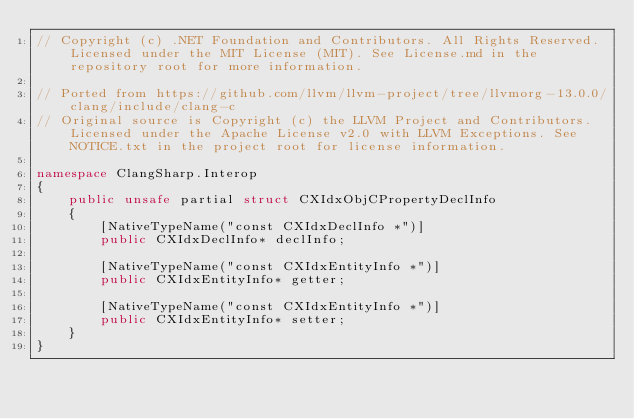Convert code to text. <code><loc_0><loc_0><loc_500><loc_500><_C#_>// Copyright (c) .NET Foundation and Contributors. All Rights Reserved. Licensed under the MIT License (MIT). See License.md in the repository root for more information.

// Ported from https://github.com/llvm/llvm-project/tree/llvmorg-13.0.0/clang/include/clang-c
// Original source is Copyright (c) the LLVM Project and Contributors. Licensed under the Apache License v2.0 with LLVM Exceptions. See NOTICE.txt in the project root for license information.

namespace ClangSharp.Interop
{
    public unsafe partial struct CXIdxObjCPropertyDeclInfo
    {
        [NativeTypeName("const CXIdxDeclInfo *")]
        public CXIdxDeclInfo* declInfo;

        [NativeTypeName("const CXIdxEntityInfo *")]
        public CXIdxEntityInfo* getter;

        [NativeTypeName("const CXIdxEntityInfo *")]
        public CXIdxEntityInfo* setter;
    }
}
</code> 